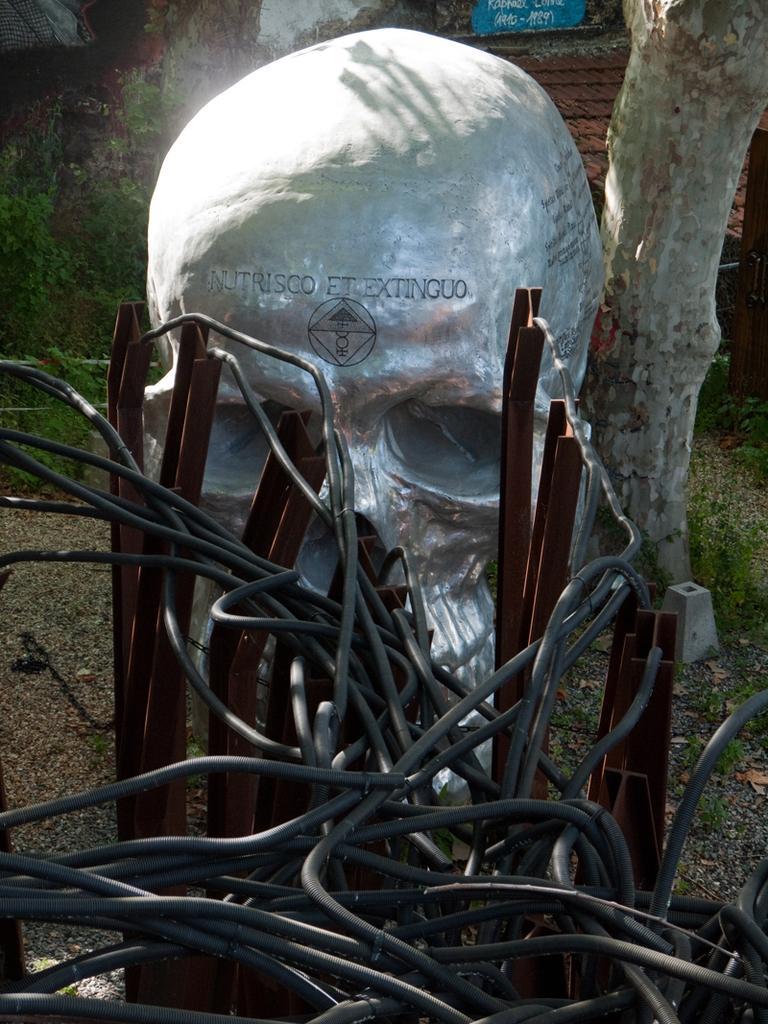Can you describe this image briefly? In this image I can see a cable wires and iron rods and sculpture of a person and stem of tree. 